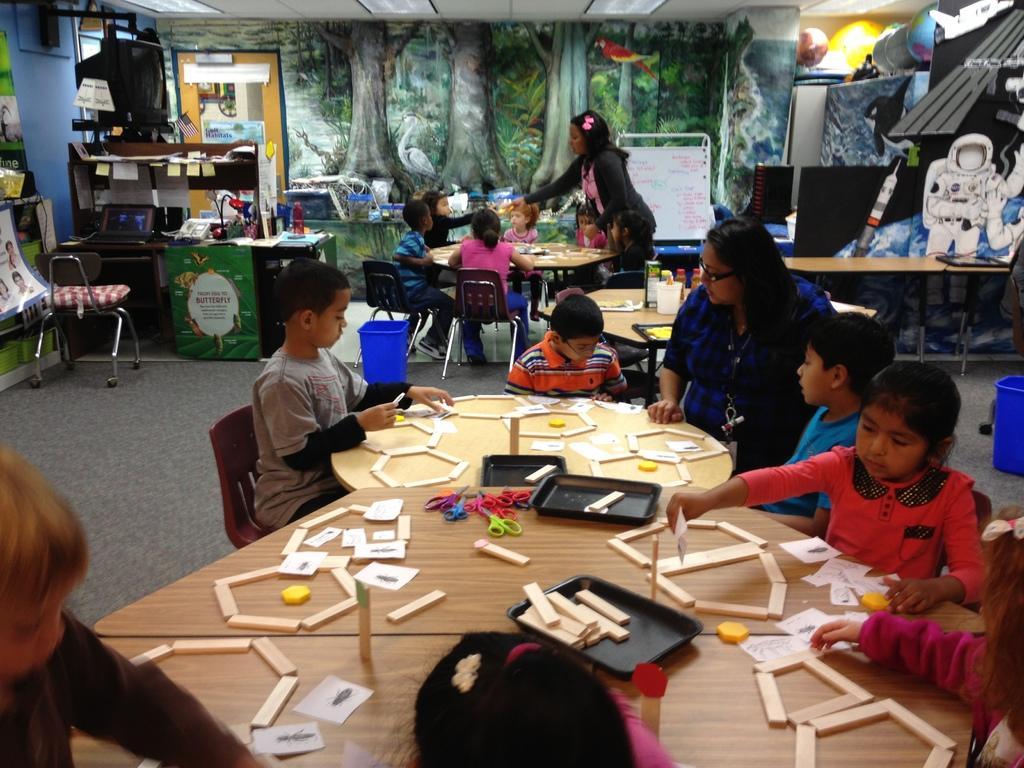Describe this image in one or two sentences. In this image we can see few children are sitting on the chairs near the table. On the table we can see few things like scissors, trays, papers and etc. In the background we can see a wall with a painting. 